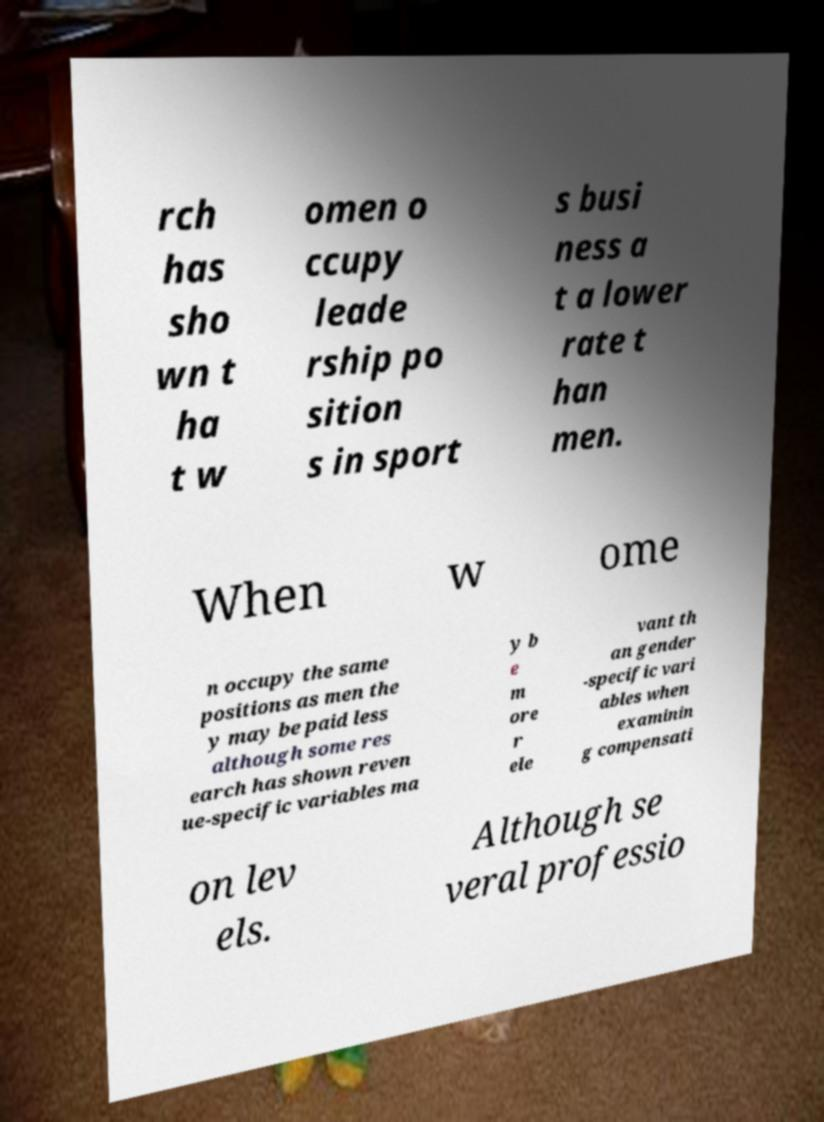Could you assist in decoding the text presented in this image and type it out clearly? rch has sho wn t ha t w omen o ccupy leade rship po sition s in sport s busi ness a t a lower rate t han men. When w ome n occupy the same positions as men the y may be paid less although some res earch has shown reven ue-specific variables ma y b e m ore r ele vant th an gender -specific vari ables when examinin g compensati on lev els. Although se veral professio 